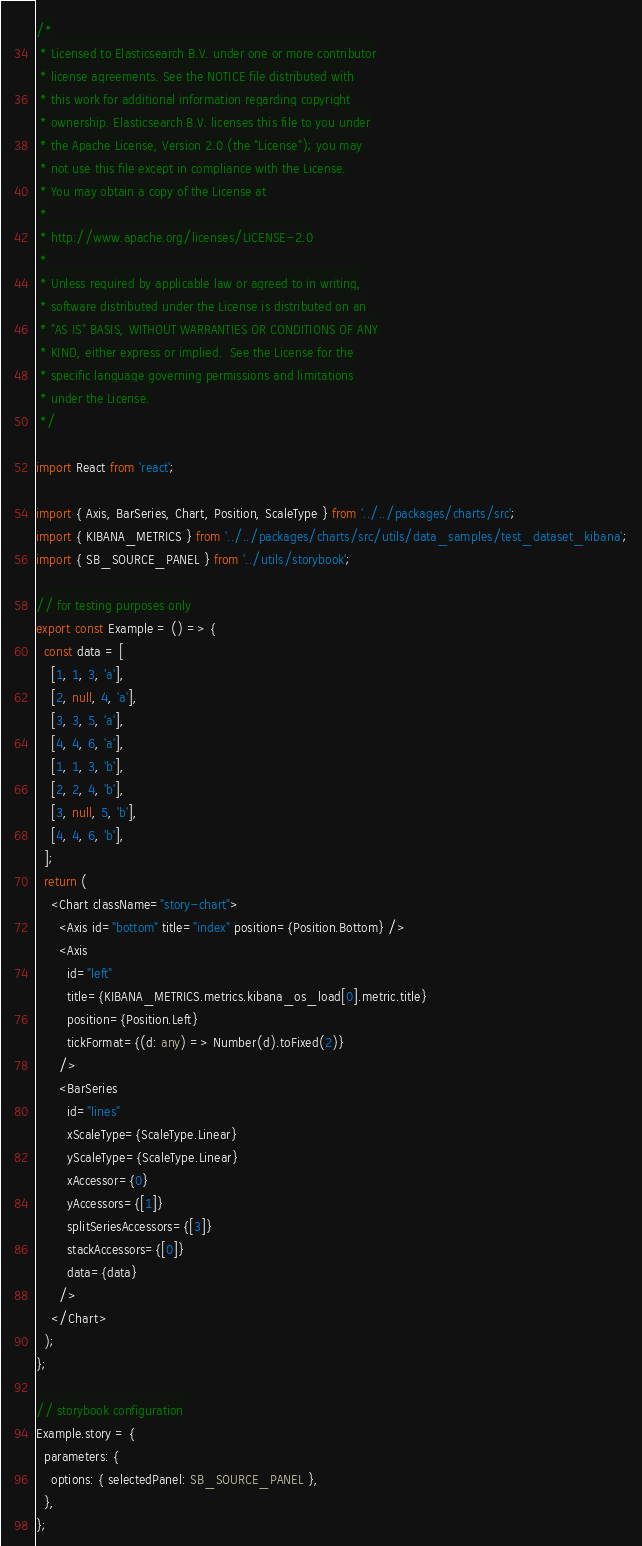Convert code to text. <code><loc_0><loc_0><loc_500><loc_500><_TypeScript_>/*
 * Licensed to Elasticsearch B.V. under one or more contributor
 * license agreements. See the NOTICE file distributed with
 * this work for additional information regarding copyright
 * ownership. Elasticsearch B.V. licenses this file to you under
 * the Apache License, Version 2.0 (the "License"); you may
 * not use this file except in compliance with the License.
 * You may obtain a copy of the License at
 *
 * http://www.apache.org/licenses/LICENSE-2.0
 *
 * Unless required by applicable law or agreed to in writing,
 * software distributed under the License is distributed on an
 * "AS IS" BASIS, WITHOUT WARRANTIES OR CONDITIONS OF ANY
 * KIND, either express or implied.  See the License for the
 * specific language governing permissions and limitations
 * under the License.
 */

import React from 'react';

import { Axis, BarSeries, Chart, Position, ScaleType } from '../../packages/charts/src';
import { KIBANA_METRICS } from '../../packages/charts/src/utils/data_samples/test_dataset_kibana';
import { SB_SOURCE_PANEL } from '../utils/storybook';

// for testing purposes only
export const Example = () => {
  const data = [
    [1, 1, 3, 'a'],
    [2, null, 4, 'a'],
    [3, 3, 5, 'a'],
    [4, 4, 6, 'a'],
    [1, 1, 3, 'b'],
    [2, 2, 4, 'b'],
    [3, null, 5, 'b'],
    [4, 4, 6, 'b'],
  ];
  return (
    <Chart className="story-chart">
      <Axis id="bottom" title="index" position={Position.Bottom} />
      <Axis
        id="left"
        title={KIBANA_METRICS.metrics.kibana_os_load[0].metric.title}
        position={Position.Left}
        tickFormat={(d: any) => Number(d).toFixed(2)}
      />
      <BarSeries
        id="lines"
        xScaleType={ScaleType.Linear}
        yScaleType={ScaleType.Linear}
        xAccessor={0}
        yAccessors={[1]}
        splitSeriesAccessors={[3]}
        stackAccessors={[0]}
        data={data}
      />
    </Chart>
  );
};

// storybook configuration
Example.story = {
  parameters: {
    options: { selectedPanel: SB_SOURCE_PANEL },
  },
};
</code> 